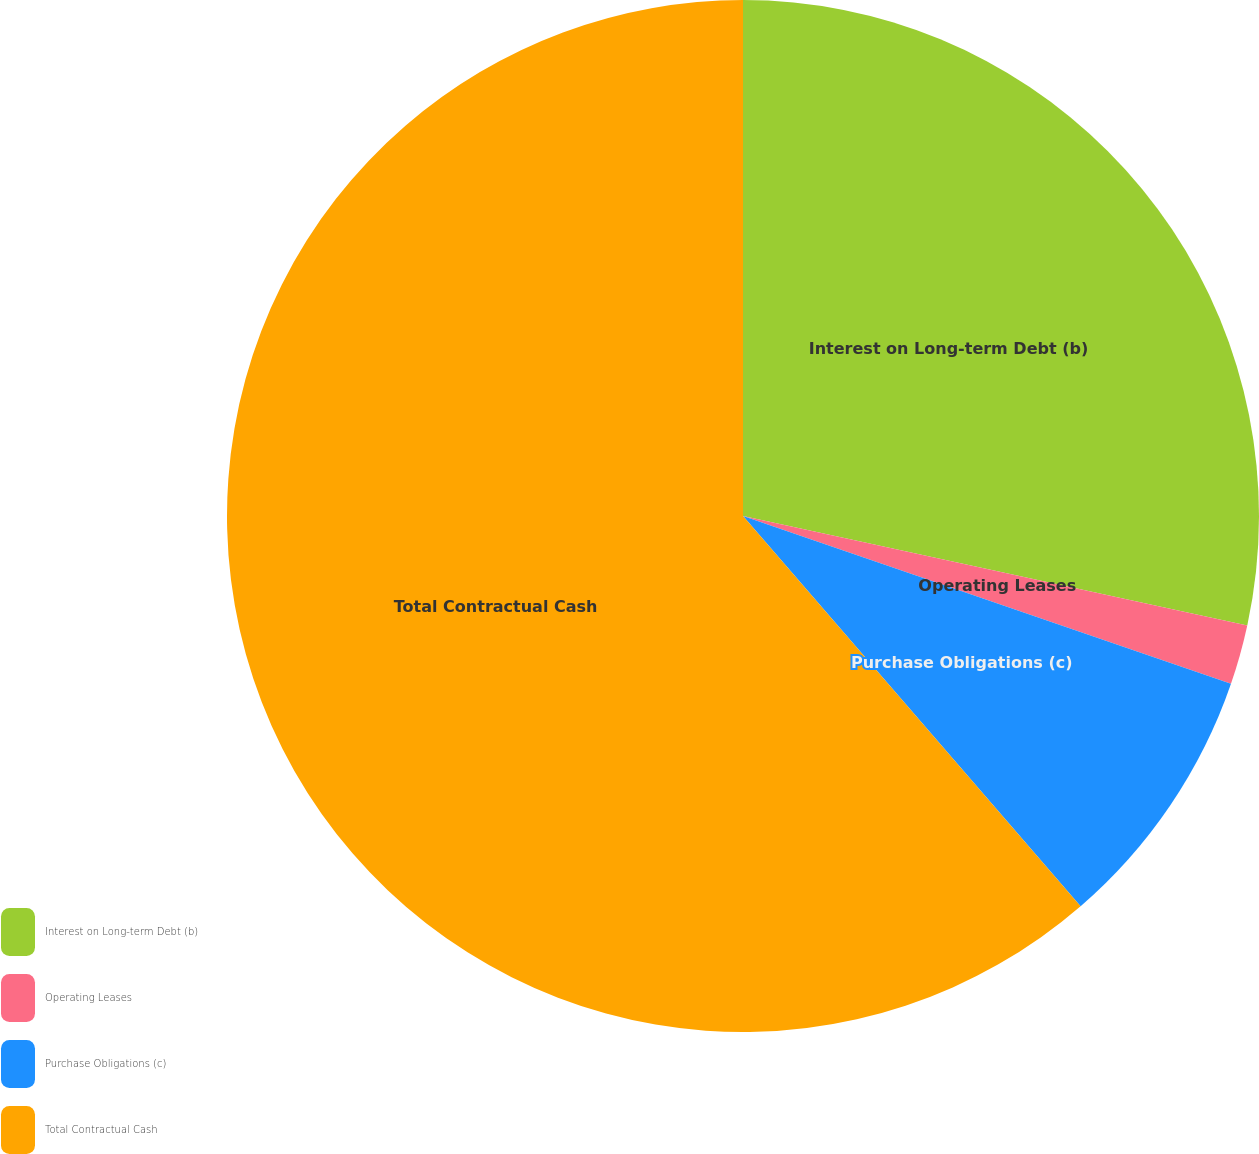<chart> <loc_0><loc_0><loc_500><loc_500><pie_chart><fcel>Interest on Long-term Debt (b)<fcel>Operating Leases<fcel>Purchase Obligations (c)<fcel>Total Contractual Cash<nl><fcel>28.4%<fcel>1.87%<fcel>8.38%<fcel>61.35%<nl></chart> 